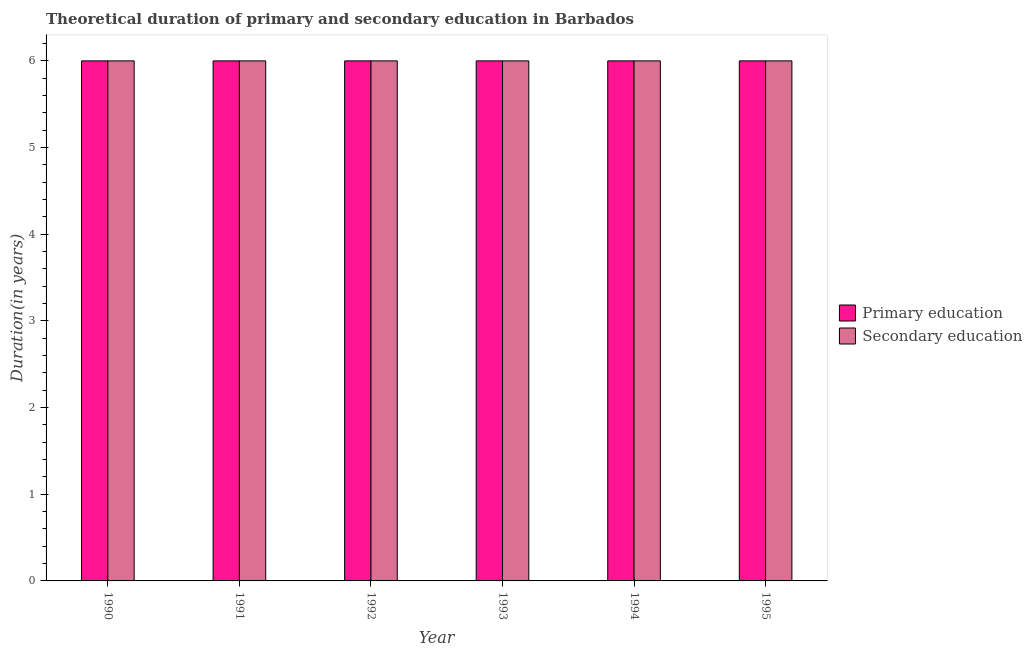Are the number of bars per tick equal to the number of legend labels?
Your response must be concise. Yes. What is the label of the 2nd group of bars from the left?
Your response must be concise. 1991. In how many cases, is the number of bars for a given year not equal to the number of legend labels?
Ensure brevity in your answer.  0. What is the total duration of primary education in the graph?
Give a very brief answer. 36. What is the difference between the duration of primary education in 1995 and the duration of secondary education in 1991?
Your answer should be very brief. 0. What is the average duration of secondary education per year?
Your response must be concise. 6. In how many years, is the duration of primary education greater than 4.8 years?
Provide a short and direct response. 6. Is the duration of secondary education in 1990 less than that in 1991?
Ensure brevity in your answer.  No. Is the difference between the duration of primary education in 1990 and 1993 greater than the difference between the duration of secondary education in 1990 and 1993?
Offer a terse response. No. Is the sum of the duration of secondary education in 1994 and 1995 greater than the maximum duration of primary education across all years?
Offer a terse response. Yes. What does the 2nd bar from the left in 1994 represents?
Offer a terse response. Secondary education. What does the 1st bar from the right in 1990 represents?
Your response must be concise. Secondary education. How many bars are there?
Give a very brief answer. 12. Are all the bars in the graph horizontal?
Your answer should be very brief. No. How many years are there in the graph?
Make the answer very short. 6. Does the graph contain any zero values?
Give a very brief answer. No. How many legend labels are there?
Provide a short and direct response. 2. How are the legend labels stacked?
Keep it short and to the point. Vertical. What is the title of the graph?
Your answer should be compact. Theoretical duration of primary and secondary education in Barbados. Does "Commercial bank branches" appear as one of the legend labels in the graph?
Ensure brevity in your answer.  No. What is the label or title of the Y-axis?
Your answer should be compact. Duration(in years). What is the Duration(in years) in Primary education in 1990?
Ensure brevity in your answer.  6. What is the Duration(in years) of Secondary education in 1990?
Provide a short and direct response. 6. What is the Duration(in years) of Primary education in 1991?
Make the answer very short. 6. What is the Duration(in years) of Primary education in 1992?
Your response must be concise. 6. What is the Duration(in years) of Secondary education in 1992?
Make the answer very short. 6. What is the Duration(in years) in Primary education in 1993?
Give a very brief answer. 6. What is the Duration(in years) in Primary education in 1994?
Ensure brevity in your answer.  6. Across all years, what is the maximum Duration(in years) of Primary education?
Offer a very short reply. 6. Across all years, what is the minimum Duration(in years) in Primary education?
Provide a short and direct response. 6. What is the difference between the Duration(in years) of Primary education in 1990 and that in 1992?
Provide a succinct answer. 0. What is the difference between the Duration(in years) in Secondary education in 1990 and that in 1993?
Your response must be concise. 0. What is the difference between the Duration(in years) of Primary education in 1990 and that in 1995?
Give a very brief answer. 0. What is the difference between the Duration(in years) in Secondary education in 1990 and that in 1995?
Offer a terse response. 0. What is the difference between the Duration(in years) in Primary education in 1991 and that in 1992?
Give a very brief answer. 0. What is the difference between the Duration(in years) in Secondary education in 1991 and that in 1992?
Provide a short and direct response. 0. What is the difference between the Duration(in years) in Primary education in 1991 and that in 1993?
Your response must be concise. 0. What is the difference between the Duration(in years) in Secondary education in 1991 and that in 1993?
Provide a short and direct response. 0. What is the difference between the Duration(in years) in Primary education in 1992 and that in 1994?
Provide a succinct answer. 0. What is the difference between the Duration(in years) of Secondary education in 1992 and that in 1994?
Your answer should be very brief. 0. What is the difference between the Duration(in years) in Primary education in 1993 and that in 1995?
Ensure brevity in your answer.  0. What is the difference between the Duration(in years) in Secondary education in 1993 and that in 1995?
Your answer should be compact. 0. What is the difference between the Duration(in years) of Primary education in 1994 and that in 1995?
Ensure brevity in your answer.  0. What is the difference between the Duration(in years) of Secondary education in 1994 and that in 1995?
Make the answer very short. 0. What is the difference between the Duration(in years) in Primary education in 1990 and the Duration(in years) in Secondary education in 1993?
Provide a short and direct response. 0. What is the difference between the Duration(in years) in Primary education in 1991 and the Duration(in years) in Secondary education in 1992?
Ensure brevity in your answer.  0. What is the difference between the Duration(in years) in Primary education in 1991 and the Duration(in years) in Secondary education in 1995?
Offer a terse response. 0. What is the difference between the Duration(in years) of Primary education in 1992 and the Duration(in years) of Secondary education in 1994?
Keep it short and to the point. 0. What is the difference between the Duration(in years) of Primary education in 1993 and the Duration(in years) of Secondary education in 1994?
Your answer should be compact. 0. What is the difference between the Duration(in years) of Primary education in 1994 and the Duration(in years) of Secondary education in 1995?
Provide a succinct answer. 0. In the year 1990, what is the difference between the Duration(in years) in Primary education and Duration(in years) in Secondary education?
Keep it short and to the point. 0. In the year 1992, what is the difference between the Duration(in years) of Primary education and Duration(in years) of Secondary education?
Your response must be concise. 0. In the year 1993, what is the difference between the Duration(in years) in Primary education and Duration(in years) in Secondary education?
Your response must be concise. 0. In the year 1994, what is the difference between the Duration(in years) in Primary education and Duration(in years) in Secondary education?
Your answer should be very brief. 0. In the year 1995, what is the difference between the Duration(in years) in Primary education and Duration(in years) in Secondary education?
Offer a very short reply. 0. What is the ratio of the Duration(in years) of Secondary education in 1990 to that in 1991?
Your answer should be compact. 1. What is the ratio of the Duration(in years) of Primary education in 1990 to that in 1992?
Offer a terse response. 1. What is the ratio of the Duration(in years) in Secondary education in 1990 to that in 1993?
Your answer should be compact. 1. What is the ratio of the Duration(in years) of Primary education in 1990 to that in 1994?
Provide a succinct answer. 1. What is the ratio of the Duration(in years) of Secondary education in 1990 to that in 1994?
Provide a short and direct response. 1. What is the ratio of the Duration(in years) in Primary education in 1990 to that in 1995?
Provide a short and direct response. 1. What is the ratio of the Duration(in years) in Secondary education in 1990 to that in 1995?
Your answer should be very brief. 1. What is the ratio of the Duration(in years) of Primary education in 1991 to that in 1993?
Your answer should be very brief. 1. What is the ratio of the Duration(in years) in Secondary education in 1991 to that in 1993?
Provide a succinct answer. 1. What is the ratio of the Duration(in years) of Primary education in 1992 to that in 1993?
Provide a short and direct response. 1. What is the ratio of the Duration(in years) in Primary education in 1992 to that in 1994?
Your response must be concise. 1. What is the ratio of the Duration(in years) in Primary education in 1993 to that in 1995?
Your response must be concise. 1. What is the ratio of the Duration(in years) in Primary education in 1994 to that in 1995?
Make the answer very short. 1. What is the ratio of the Duration(in years) in Secondary education in 1994 to that in 1995?
Make the answer very short. 1. What is the difference between the highest and the second highest Duration(in years) in Secondary education?
Offer a very short reply. 0. What is the difference between the highest and the lowest Duration(in years) in Secondary education?
Keep it short and to the point. 0. 